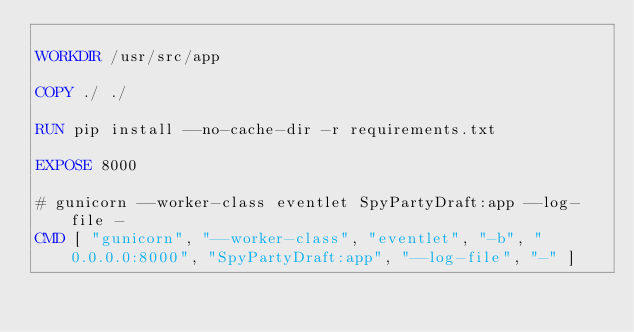Convert code to text. <code><loc_0><loc_0><loc_500><loc_500><_Dockerfile_>
WORKDIR /usr/src/app

COPY ./ ./

RUN pip install --no-cache-dir -r requirements.txt

EXPOSE 8000

# gunicorn --worker-class eventlet SpyPartyDraft:app --log-file -
CMD [ "gunicorn", "--worker-class", "eventlet", "-b", "0.0.0.0:8000", "SpyPartyDraft:app", "--log-file", "-" ]</code> 